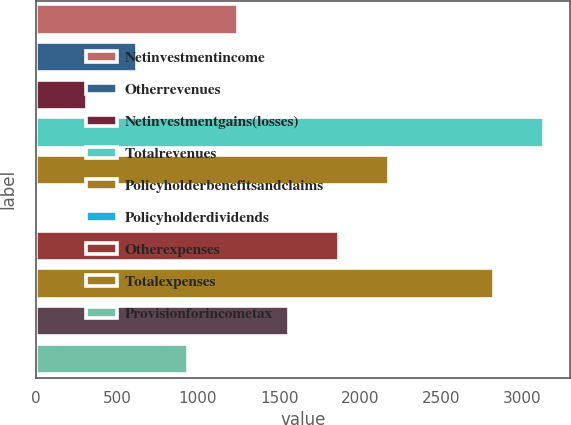<chart> <loc_0><loc_0><loc_500><loc_500><bar_chart><fcel>Netinvestmentincome<fcel>Otherrevenues<fcel>Netinvestmentgains(losses)<fcel>Totalrevenues<fcel>Policyholderbenefitsandclaims<fcel>Policyholderdividends<fcel>Otherexpenses<fcel>Totalexpenses<fcel>Unnamed: 8<fcel>Provisionforincometax<nl><fcel>1247<fcel>625<fcel>314<fcel>3136<fcel>2180<fcel>3<fcel>1869<fcel>2825<fcel>1558<fcel>936<nl></chart> 